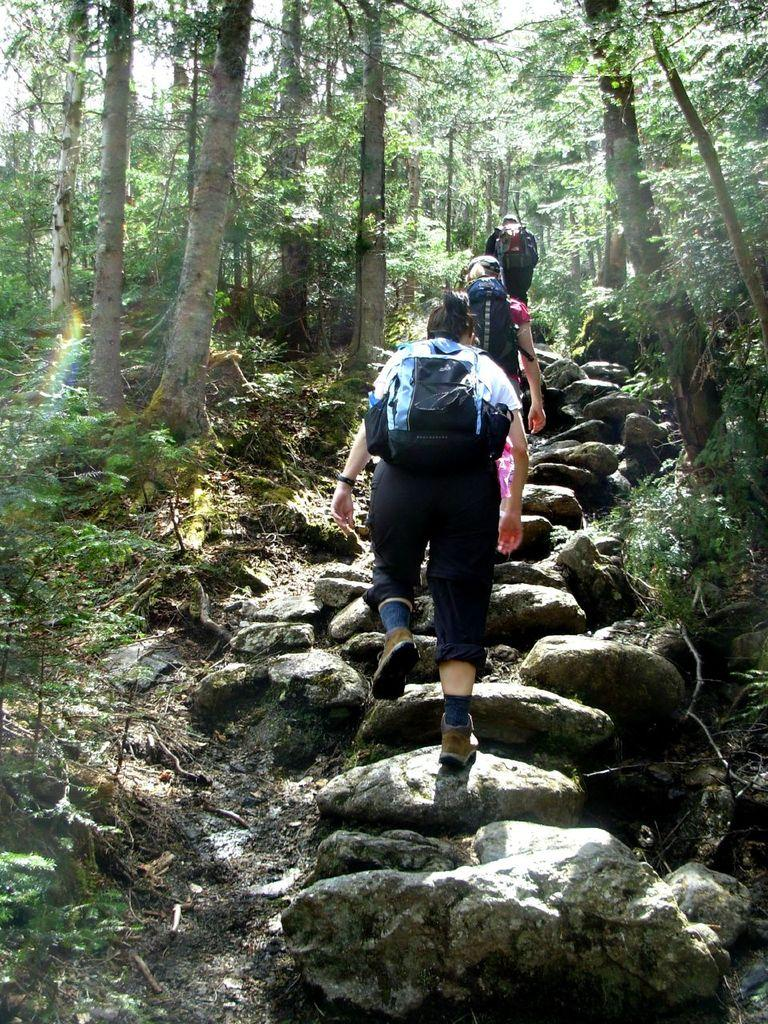Who or what can be seen in the image? There are persons in the image. What is the setting of the image? The persons are between trees. What are the persons wearing? The persons are wearing clothes. What are the persons carrying? The persons are carrying bags. Can you see any ghosts in the image? There are no ghosts present in the image. What type of lock is being used by the persons in the image? There is no lock visible in the image; the persons are carrying bags, but no locks are mentioned in the provided facts. 